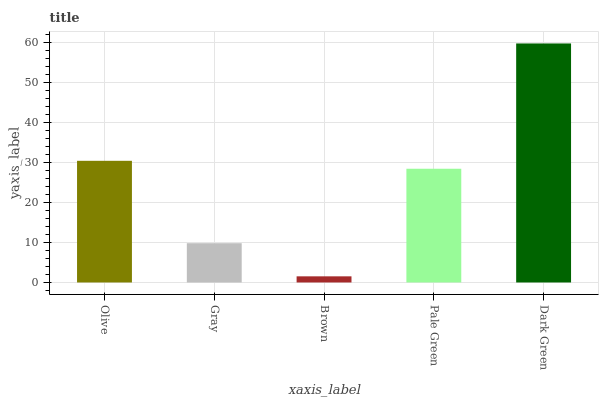Is Brown the minimum?
Answer yes or no. Yes. Is Dark Green the maximum?
Answer yes or no. Yes. Is Gray the minimum?
Answer yes or no. No. Is Gray the maximum?
Answer yes or no. No. Is Olive greater than Gray?
Answer yes or no. Yes. Is Gray less than Olive?
Answer yes or no. Yes. Is Gray greater than Olive?
Answer yes or no. No. Is Olive less than Gray?
Answer yes or no. No. Is Pale Green the high median?
Answer yes or no. Yes. Is Pale Green the low median?
Answer yes or no. Yes. Is Gray the high median?
Answer yes or no. No. Is Dark Green the low median?
Answer yes or no. No. 